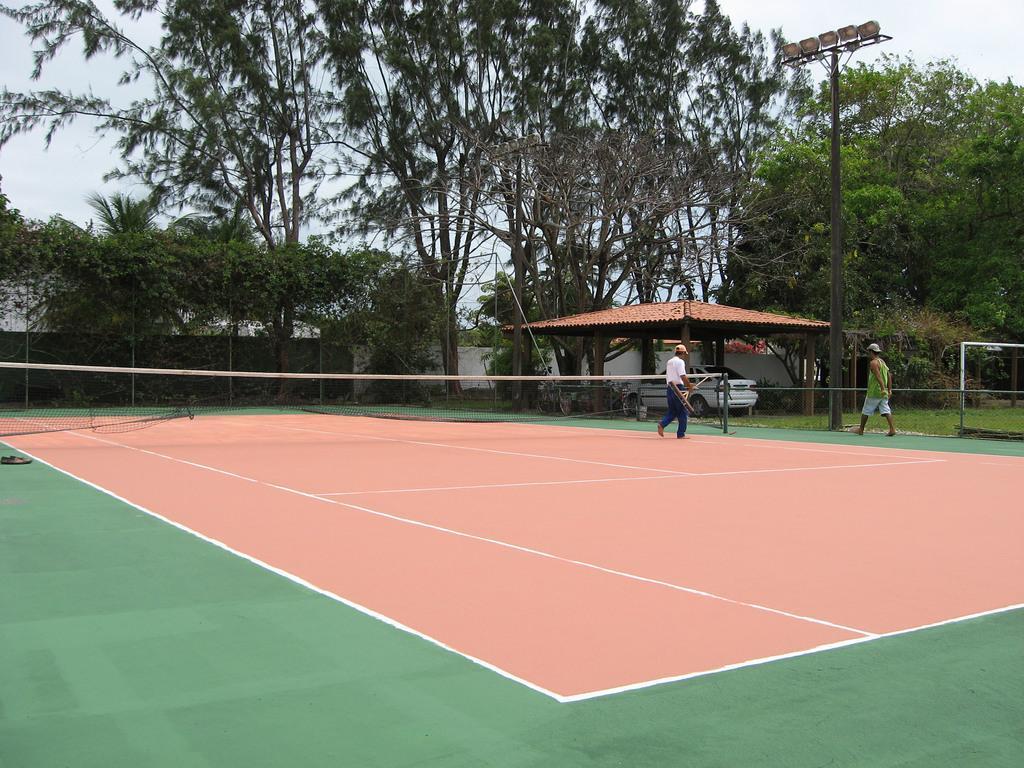In one or two sentences, can you explain what this image depicts? In this image I can see two persons walking, background I can see a car in white color, trees in green color, a light pole, and sky in white color. 